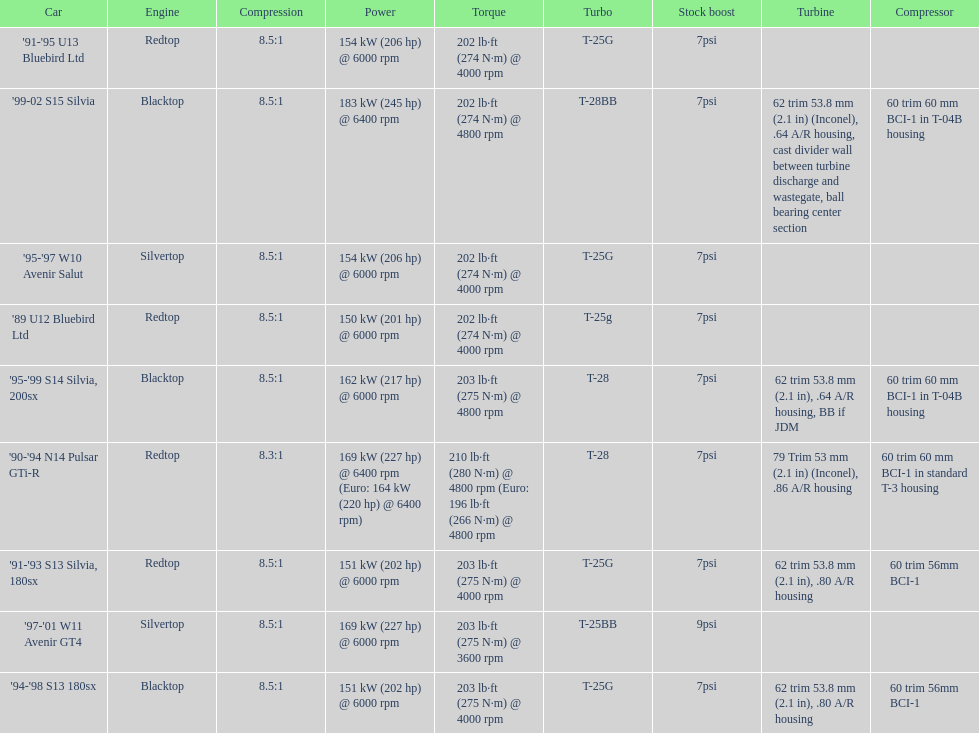Could you parse the entire table as a dict? {'header': ['Car', 'Engine', 'Compression', 'Power', 'Torque', 'Turbo', 'Stock boost', 'Turbine', 'Compressor'], 'rows': [["'91-'95 U13 Bluebird Ltd", 'Redtop', '8.5:1', '154\xa0kW (206\xa0hp) @ 6000 rpm', '202\xa0lb·ft (274\xa0N·m) @ 4000 rpm', 'T-25G', '7psi', '', ''], ["'99-02 S15 Silvia", 'Blacktop', '8.5:1', '183\xa0kW (245\xa0hp) @ 6400 rpm', '202\xa0lb·ft (274\xa0N·m) @ 4800 rpm', 'T-28BB', '7psi', '62 trim 53.8\xa0mm (2.1\xa0in) (Inconel), .64 A/R housing, cast divider wall between turbine discharge and wastegate, ball bearing center section', '60 trim 60\xa0mm BCI-1 in T-04B housing'], ["'95-'97 W10 Avenir Salut", 'Silvertop', '8.5:1', '154\xa0kW (206\xa0hp) @ 6000 rpm', '202\xa0lb·ft (274\xa0N·m) @ 4000 rpm', 'T-25G', '7psi', '', ''], ["'89 U12 Bluebird Ltd", 'Redtop', '8.5:1', '150\xa0kW (201\xa0hp) @ 6000 rpm', '202\xa0lb·ft (274\xa0N·m) @ 4000 rpm', 'T-25g', '7psi', '', ''], ["'95-'99 S14 Silvia, 200sx", 'Blacktop', '8.5:1', '162\xa0kW (217\xa0hp) @ 6000 rpm', '203\xa0lb·ft (275\xa0N·m) @ 4800 rpm', 'T-28', '7psi', '62 trim 53.8\xa0mm (2.1\xa0in), .64 A/R housing, BB if JDM', '60 trim 60\xa0mm BCI-1 in T-04B housing'], ["'90-'94 N14 Pulsar GTi-R", 'Redtop', '8.3:1', '169\xa0kW (227\xa0hp) @ 6400 rpm (Euro: 164\xa0kW (220\xa0hp) @ 6400 rpm)', '210\xa0lb·ft (280\xa0N·m) @ 4800 rpm (Euro: 196\xa0lb·ft (266\xa0N·m) @ 4800 rpm', 'T-28', '7psi', '79 Trim 53\xa0mm (2.1\xa0in) (Inconel), .86 A/R housing', '60 trim 60\xa0mm BCI-1 in standard T-3 housing'], ["'91-'93 S13 Silvia, 180sx", 'Redtop', '8.5:1', '151\xa0kW (202\xa0hp) @ 6000 rpm', '203\xa0lb·ft (275\xa0N·m) @ 4000 rpm', 'T-25G', '7psi', '62 trim 53.8\xa0mm (2.1\xa0in), .80 A/R housing', '60 trim 56mm BCI-1'], ["'97-'01 W11 Avenir GT4", 'Silvertop', '8.5:1', '169\xa0kW (227\xa0hp) @ 6000 rpm', '203\xa0lb·ft (275\xa0N·m) @ 3600 rpm', 'T-25BB', '9psi', '', ''], ["'94-'98 S13 180sx", 'Blacktop', '8.5:1', '151\xa0kW (202\xa0hp) @ 6000 rpm', '203\xa0lb·ft (275\xa0N·m) @ 4000 rpm', 'T-25G', '7psi', '62 trim 53.8\xa0mm (2.1\xa0in), .80 A/R housing', '60 trim 56mm BCI-1']]} Which car is the only one with more than 230 hp? '99-02 S15 Silvia. 